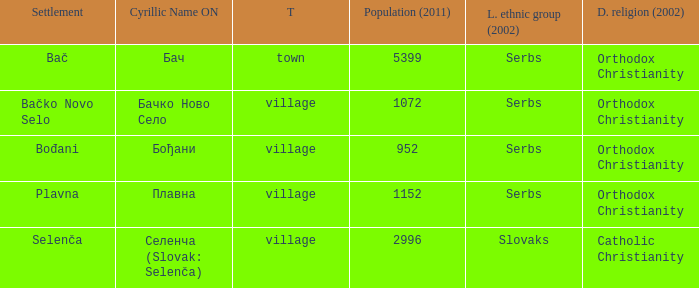What is the smallest population listed? 952.0. 